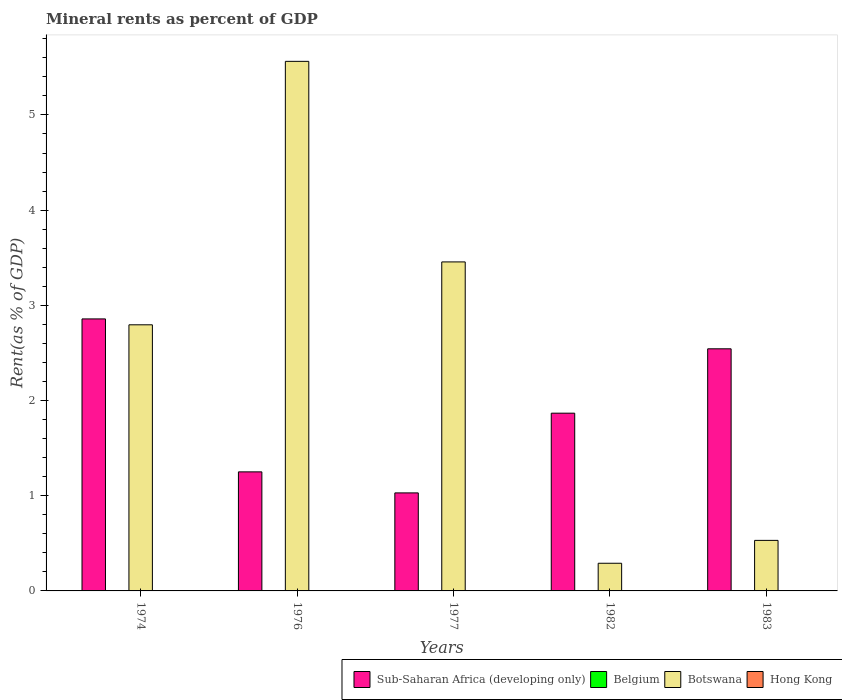How many different coloured bars are there?
Give a very brief answer. 4. How many groups of bars are there?
Make the answer very short. 5. How many bars are there on the 2nd tick from the right?
Your answer should be very brief. 4. What is the label of the 3rd group of bars from the left?
Offer a very short reply. 1977. What is the mineral rent in Hong Kong in 1983?
Make the answer very short. 0. Across all years, what is the maximum mineral rent in Botswana?
Give a very brief answer. 5.56. Across all years, what is the minimum mineral rent in Sub-Saharan Africa (developing only)?
Provide a succinct answer. 1.03. In which year was the mineral rent in Hong Kong maximum?
Make the answer very short. 1976. In which year was the mineral rent in Hong Kong minimum?
Offer a terse response. 1974. What is the total mineral rent in Hong Kong in the graph?
Ensure brevity in your answer.  0. What is the difference between the mineral rent in Belgium in 1976 and that in 1983?
Make the answer very short. 0. What is the difference between the mineral rent in Botswana in 1974 and the mineral rent in Belgium in 1983?
Make the answer very short. 2.8. What is the average mineral rent in Botswana per year?
Ensure brevity in your answer.  2.53. In the year 1976, what is the difference between the mineral rent in Hong Kong and mineral rent in Belgium?
Make the answer very short. -0. In how many years, is the mineral rent in Belgium greater than 5.6 %?
Keep it short and to the point. 0. What is the ratio of the mineral rent in Botswana in 1974 to that in 1983?
Keep it short and to the point. 5.27. Is the difference between the mineral rent in Hong Kong in 1976 and 1977 greater than the difference between the mineral rent in Belgium in 1976 and 1977?
Give a very brief answer. No. What is the difference between the highest and the second highest mineral rent in Hong Kong?
Provide a succinct answer. 0. What is the difference between the highest and the lowest mineral rent in Belgium?
Your response must be concise. 0. In how many years, is the mineral rent in Belgium greater than the average mineral rent in Belgium taken over all years?
Give a very brief answer. 2. Is the sum of the mineral rent in Sub-Saharan Africa (developing only) in 1977 and 1983 greater than the maximum mineral rent in Hong Kong across all years?
Provide a succinct answer. Yes. What does the 3rd bar from the left in 1983 represents?
Provide a short and direct response. Botswana. What does the 1st bar from the right in 1983 represents?
Give a very brief answer. Hong Kong. Are all the bars in the graph horizontal?
Your answer should be compact. No. What is the difference between two consecutive major ticks on the Y-axis?
Offer a terse response. 1. Does the graph contain any zero values?
Give a very brief answer. No. Where does the legend appear in the graph?
Make the answer very short. Bottom right. How many legend labels are there?
Your answer should be very brief. 4. What is the title of the graph?
Keep it short and to the point. Mineral rents as percent of GDP. Does "Israel" appear as one of the legend labels in the graph?
Give a very brief answer. No. What is the label or title of the X-axis?
Your response must be concise. Years. What is the label or title of the Y-axis?
Offer a very short reply. Rent(as % of GDP). What is the Rent(as % of GDP) in Sub-Saharan Africa (developing only) in 1974?
Ensure brevity in your answer.  2.86. What is the Rent(as % of GDP) in Belgium in 1974?
Give a very brief answer. 0. What is the Rent(as % of GDP) in Botswana in 1974?
Your response must be concise. 2.8. What is the Rent(as % of GDP) in Hong Kong in 1974?
Provide a short and direct response. 0. What is the Rent(as % of GDP) in Sub-Saharan Africa (developing only) in 1976?
Your answer should be compact. 1.25. What is the Rent(as % of GDP) in Belgium in 1976?
Provide a succinct answer. 0. What is the Rent(as % of GDP) in Botswana in 1976?
Ensure brevity in your answer.  5.56. What is the Rent(as % of GDP) in Hong Kong in 1976?
Your answer should be compact. 0. What is the Rent(as % of GDP) in Sub-Saharan Africa (developing only) in 1977?
Keep it short and to the point. 1.03. What is the Rent(as % of GDP) in Belgium in 1977?
Offer a very short reply. 0. What is the Rent(as % of GDP) of Botswana in 1977?
Ensure brevity in your answer.  3.46. What is the Rent(as % of GDP) of Hong Kong in 1977?
Make the answer very short. 0. What is the Rent(as % of GDP) of Sub-Saharan Africa (developing only) in 1982?
Provide a succinct answer. 1.87. What is the Rent(as % of GDP) in Belgium in 1982?
Ensure brevity in your answer.  5.1557649485168e-5. What is the Rent(as % of GDP) in Botswana in 1982?
Keep it short and to the point. 0.29. What is the Rent(as % of GDP) of Hong Kong in 1982?
Your answer should be very brief. 0. What is the Rent(as % of GDP) in Sub-Saharan Africa (developing only) in 1983?
Keep it short and to the point. 2.54. What is the Rent(as % of GDP) of Belgium in 1983?
Provide a succinct answer. 2.2873388575686e-5. What is the Rent(as % of GDP) of Botswana in 1983?
Provide a succinct answer. 0.53. What is the Rent(as % of GDP) of Hong Kong in 1983?
Your answer should be compact. 0. Across all years, what is the maximum Rent(as % of GDP) in Sub-Saharan Africa (developing only)?
Keep it short and to the point. 2.86. Across all years, what is the maximum Rent(as % of GDP) in Belgium?
Your response must be concise. 0. Across all years, what is the maximum Rent(as % of GDP) in Botswana?
Make the answer very short. 5.56. Across all years, what is the maximum Rent(as % of GDP) of Hong Kong?
Offer a very short reply. 0. Across all years, what is the minimum Rent(as % of GDP) in Sub-Saharan Africa (developing only)?
Your answer should be compact. 1.03. Across all years, what is the minimum Rent(as % of GDP) of Belgium?
Your response must be concise. 2.2873388575686e-5. Across all years, what is the minimum Rent(as % of GDP) of Botswana?
Make the answer very short. 0.29. Across all years, what is the minimum Rent(as % of GDP) of Hong Kong?
Provide a succinct answer. 0. What is the total Rent(as % of GDP) of Sub-Saharan Africa (developing only) in the graph?
Your response must be concise. 9.55. What is the total Rent(as % of GDP) in Belgium in the graph?
Your answer should be very brief. 0.01. What is the total Rent(as % of GDP) in Botswana in the graph?
Provide a short and direct response. 12.64. What is the total Rent(as % of GDP) of Hong Kong in the graph?
Make the answer very short. 0. What is the difference between the Rent(as % of GDP) in Sub-Saharan Africa (developing only) in 1974 and that in 1976?
Give a very brief answer. 1.61. What is the difference between the Rent(as % of GDP) in Belgium in 1974 and that in 1976?
Your answer should be very brief. -0. What is the difference between the Rent(as % of GDP) of Botswana in 1974 and that in 1976?
Ensure brevity in your answer.  -2.77. What is the difference between the Rent(as % of GDP) of Hong Kong in 1974 and that in 1976?
Provide a short and direct response. -0. What is the difference between the Rent(as % of GDP) of Sub-Saharan Africa (developing only) in 1974 and that in 1977?
Offer a terse response. 1.83. What is the difference between the Rent(as % of GDP) of Belgium in 1974 and that in 1977?
Make the answer very short. 0. What is the difference between the Rent(as % of GDP) in Botswana in 1974 and that in 1977?
Make the answer very short. -0.66. What is the difference between the Rent(as % of GDP) in Hong Kong in 1974 and that in 1977?
Offer a terse response. -0. What is the difference between the Rent(as % of GDP) in Sub-Saharan Africa (developing only) in 1974 and that in 1982?
Provide a succinct answer. 0.99. What is the difference between the Rent(as % of GDP) in Belgium in 1974 and that in 1982?
Make the answer very short. 0. What is the difference between the Rent(as % of GDP) of Botswana in 1974 and that in 1982?
Provide a short and direct response. 2.5. What is the difference between the Rent(as % of GDP) of Hong Kong in 1974 and that in 1982?
Keep it short and to the point. -0. What is the difference between the Rent(as % of GDP) of Sub-Saharan Africa (developing only) in 1974 and that in 1983?
Give a very brief answer. 0.31. What is the difference between the Rent(as % of GDP) of Belgium in 1974 and that in 1983?
Your answer should be very brief. 0. What is the difference between the Rent(as % of GDP) of Botswana in 1974 and that in 1983?
Offer a very short reply. 2.26. What is the difference between the Rent(as % of GDP) in Sub-Saharan Africa (developing only) in 1976 and that in 1977?
Provide a succinct answer. 0.22. What is the difference between the Rent(as % of GDP) of Belgium in 1976 and that in 1977?
Provide a short and direct response. 0. What is the difference between the Rent(as % of GDP) of Botswana in 1976 and that in 1977?
Your response must be concise. 2.11. What is the difference between the Rent(as % of GDP) of Sub-Saharan Africa (developing only) in 1976 and that in 1982?
Provide a short and direct response. -0.62. What is the difference between the Rent(as % of GDP) of Belgium in 1976 and that in 1982?
Offer a terse response. 0. What is the difference between the Rent(as % of GDP) of Botswana in 1976 and that in 1982?
Your answer should be compact. 5.27. What is the difference between the Rent(as % of GDP) in Hong Kong in 1976 and that in 1982?
Your answer should be compact. 0. What is the difference between the Rent(as % of GDP) of Sub-Saharan Africa (developing only) in 1976 and that in 1983?
Your response must be concise. -1.29. What is the difference between the Rent(as % of GDP) of Belgium in 1976 and that in 1983?
Give a very brief answer. 0. What is the difference between the Rent(as % of GDP) in Botswana in 1976 and that in 1983?
Your response must be concise. 5.03. What is the difference between the Rent(as % of GDP) of Hong Kong in 1976 and that in 1983?
Make the answer very short. 0. What is the difference between the Rent(as % of GDP) in Sub-Saharan Africa (developing only) in 1977 and that in 1982?
Your answer should be compact. -0.84. What is the difference between the Rent(as % of GDP) in Belgium in 1977 and that in 1982?
Your answer should be very brief. 0. What is the difference between the Rent(as % of GDP) in Botswana in 1977 and that in 1982?
Offer a very short reply. 3.17. What is the difference between the Rent(as % of GDP) of Hong Kong in 1977 and that in 1982?
Make the answer very short. 0. What is the difference between the Rent(as % of GDP) in Sub-Saharan Africa (developing only) in 1977 and that in 1983?
Give a very brief answer. -1.51. What is the difference between the Rent(as % of GDP) in Belgium in 1977 and that in 1983?
Offer a very short reply. 0. What is the difference between the Rent(as % of GDP) in Botswana in 1977 and that in 1983?
Ensure brevity in your answer.  2.93. What is the difference between the Rent(as % of GDP) of Hong Kong in 1977 and that in 1983?
Give a very brief answer. 0. What is the difference between the Rent(as % of GDP) of Sub-Saharan Africa (developing only) in 1982 and that in 1983?
Offer a terse response. -0.68. What is the difference between the Rent(as % of GDP) of Botswana in 1982 and that in 1983?
Provide a succinct answer. -0.24. What is the difference between the Rent(as % of GDP) of Sub-Saharan Africa (developing only) in 1974 and the Rent(as % of GDP) of Belgium in 1976?
Keep it short and to the point. 2.85. What is the difference between the Rent(as % of GDP) of Sub-Saharan Africa (developing only) in 1974 and the Rent(as % of GDP) of Botswana in 1976?
Provide a succinct answer. -2.71. What is the difference between the Rent(as % of GDP) in Sub-Saharan Africa (developing only) in 1974 and the Rent(as % of GDP) in Hong Kong in 1976?
Your response must be concise. 2.86. What is the difference between the Rent(as % of GDP) of Belgium in 1974 and the Rent(as % of GDP) of Botswana in 1976?
Provide a short and direct response. -5.56. What is the difference between the Rent(as % of GDP) of Belgium in 1974 and the Rent(as % of GDP) of Hong Kong in 1976?
Offer a terse response. 0. What is the difference between the Rent(as % of GDP) in Botswana in 1974 and the Rent(as % of GDP) in Hong Kong in 1976?
Keep it short and to the point. 2.79. What is the difference between the Rent(as % of GDP) of Sub-Saharan Africa (developing only) in 1974 and the Rent(as % of GDP) of Belgium in 1977?
Your answer should be compact. 2.86. What is the difference between the Rent(as % of GDP) in Sub-Saharan Africa (developing only) in 1974 and the Rent(as % of GDP) in Botswana in 1977?
Your answer should be very brief. -0.6. What is the difference between the Rent(as % of GDP) of Sub-Saharan Africa (developing only) in 1974 and the Rent(as % of GDP) of Hong Kong in 1977?
Make the answer very short. 2.86. What is the difference between the Rent(as % of GDP) in Belgium in 1974 and the Rent(as % of GDP) in Botswana in 1977?
Keep it short and to the point. -3.45. What is the difference between the Rent(as % of GDP) in Belgium in 1974 and the Rent(as % of GDP) in Hong Kong in 1977?
Offer a very short reply. 0. What is the difference between the Rent(as % of GDP) in Botswana in 1974 and the Rent(as % of GDP) in Hong Kong in 1977?
Your answer should be very brief. 2.79. What is the difference between the Rent(as % of GDP) of Sub-Saharan Africa (developing only) in 1974 and the Rent(as % of GDP) of Belgium in 1982?
Offer a very short reply. 2.86. What is the difference between the Rent(as % of GDP) of Sub-Saharan Africa (developing only) in 1974 and the Rent(as % of GDP) of Botswana in 1982?
Make the answer very short. 2.57. What is the difference between the Rent(as % of GDP) in Sub-Saharan Africa (developing only) in 1974 and the Rent(as % of GDP) in Hong Kong in 1982?
Offer a very short reply. 2.86. What is the difference between the Rent(as % of GDP) in Belgium in 1974 and the Rent(as % of GDP) in Botswana in 1982?
Give a very brief answer. -0.29. What is the difference between the Rent(as % of GDP) in Belgium in 1974 and the Rent(as % of GDP) in Hong Kong in 1982?
Offer a very short reply. 0. What is the difference between the Rent(as % of GDP) in Botswana in 1974 and the Rent(as % of GDP) in Hong Kong in 1982?
Offer a very short reply. 2.79. What is the difference between the Rent(as % of GDP) in Sub-Saharan Africa (developing only) in 1974 and the Rent(as % of GDP) in Belgium in 1983?
Your response must be concise. 2.86. What is the difference between the Rent(as % of GDP) in Sub-Saharan Africa (developing only) in 1974 and the Rent(as % of GDP) in Botswana in 1983?
Give a very brief answer. 2.33. What is the difference between the Rent(as % of GDP) of Sub-Saharan Africa (developing only) in 1974 and the Rent(as % of GDP) of Hong Kong in 1983?
Provide a succinct answer. 2.86. What is the difference between the Rent(as % of GDP) of Belgium in 1974 and the Rent(as % of GDP) of Botswana in 1983?
Make the answer very short. -0.53. What is the difference between the Rent(as % of GDP) in Belgium in 1974 and the Rent(as % of GDP) in Hong Kong in 1983?
Offer a terse response. 0. What is the difference between the Rent(as % of GDP) in Botswana in 1974 and the Rent(as % of GDP) in Hong Kong in 1983?
Offer a very short reply. 2.79. What is the difference between the Rent(as % of GDP) of Sub-Saharan Africa (developing only) in 1976 and the Rent(as % of GDP) of Belgium in 1977?
Keep it short and to the point. 1.25. What is the difference between the Rent(as % of GDP) in Sub-Saharan Africa (developing only) in 1976 and the Rent(as % of GDP) in Botswana in 1977?
Your answer should be compact. -2.21. What is the difference between the Rent(as % of GDP) in Sub-Saharan Africa (developing only) in 1976 and the Rent(as % of GDP) in Hong Kong in 1977?
Your answer should be very brief. 1.25. What is the difference between the Rent(as % of GDP) of Belgium in 1976 and the Rent(as % of GDP) of Botswana in 1977?
Provide a succinct answer. -3.45. What is the difference between the Rent(as % of GDP) of Belgium in 1976 and the Rent(as % of GDP) of Hong Kong in 1977?
Give a very brief answer. 0. What is the difference between the Rent(as % of GDP) in Botswana in 1976 and the Rent(as % of GDP) in Hong Kong in 1977?
Give a very brief answer. 5.56. What is the difference between the Rent(as % of GDP) in Sub-Saharan Africa (developing only) in 1976 and the Rent(as % of GDP) in Belgium in 1982?
Offer a very short reply. 1.25. What is the difference between the Rent(as % of GDP) of Sub-Saharan Africa (developing only) in 1976 and the Rent(as % of GDP) of Hong Kong in 1982?
Provide a succinct answer. 1.25. What is the difference between the Rent(as % of GDP) of Belgium in 1976 and the Rent(as % of GDP) of Botswana in 1982?
Give a very brief answer. -0.29. What is the difference between the Rent(as % of GDP) in Belgium in 1976 and the Rent(as % of GDP) in Hong Kong in 1982?
Offer a terse response. 0. What is the difference between the Rent(as % of GDP) of Botswana in 1976 and the Rent(as % of GDP) of Hong Kong in 1982?
Provide a short and direct response. 5.56. What is the difference between the Rent(as % of GDP) in Sub-Saharan Africa (developing only) in 1976 and the Rent(as % of GDP) in Belgium in 1983?
Provide a succinct answer. 1.25. What is the difference between the Rent(as % of GDP) of Sub-Saharan Africa (developing only) in 1976 and the Rent(as % of GDP) of Botswana in 1983?
Ensure brevity in your answer.  0.72. What is the difference between the Rent(as % of GDP) in Sub-Saharan Africa (developing only) in 1976 and the Rent(as % of GDP) in Hong Kong in 1983?
Ensure brevity in your answer.  1.25. What is the difference between the Rent(as % of GDP) in Belgium in 1976 and the Rent(as % of GDP) in Botswana in 1983?
Offer a terse response. -0.53. What is the difference between the Rent(as % of GDP) of Belgium in 1976 and the Rent(as % of GDP) of Hong Kong in 1983?
Keep it short and to the point. 0. What is the difference between the Rent(as % of GDP) of Botswana in 1976 and the Rent(as % of GDP) of Hong Kong in 1983?
Make the answer very short. 5.56. What is the difference between the Rent(as % of GDP) in Sub-Saharan Africa (developing only) in 1977 and the Rent(as % of GDP) in Belgium in 1982?
Your answer should be compact. 1.03. What is the difference between the Rent(as % of GDP) in Sub-Saharan Africa (developing only) in 1977 and the Rent(as % of GDP) in Botswana in 1982?
Provide a short and direct response. 0.74. What is the difference between the Rent(as % of GDP) of Sub-Saharan Africa (developing only) in 1977 and the Rent(as % of GDP) of Hong Kong in 1982?
Make the answer very short. 1.03. What is the difference between the Rent(as % of GDP) of Belgium in 1977 and the Rent(as % of GDP) of Botswana in 1982?
Your answer should be compact. -0.29. What is the difference between the Rent(as % of GDP) in Botswana in 1977 and the Rent(as % of GDP) in Hong Kong in 1982?
Your response must be concise. 3.46. What is the difference between the Rent(as % of GDP) in Sub-Saharan Africa (developing only) in 1977 and the Rent(as % of GDP) in Belgium in 1983?
Make the answer very short. 1.03. What is the difference between the Rent(as % of GDP) in Sub-Saharan Africa (developing only) in 1977 and the Rent(as % of GDP) in Botswana in 1983?
Offer a very short reply. 0.5. What is the difference between the Rent(as % of GDP) of Sub-Saharan Africa (developing only) in 1977 and the Rent(as % of GDP) of Hong Kong in 1983?
Offer a terse response. 1.03. What is the difference between the Rent(as % of GDP) in Belgium in 1977 and the Rent(as % of GDP) in Botswana in 1983?
Give a very brief answer. -0.53. What is the difference between the Rent(as % of GDP) of Belgium in 1977 and the Rent(as % of GDP) of Hong Kong in 1983?
Keep it short and to the point. 0. What is the difference between the Rent(as % of GDP) of Botswana in 1977 and the Rent(as % of GDP) of Hong Kong in 1983?
Offer a very short reply. 3.46. What is the difference between the Rent(as % of GDP) in Sub-Saharan Africa (developing only) in 1982 and the Rent(as % of GDP) in Belgium in 1983?
Your answer should be compact. 1.87. What is the difference between the Rent(as % of GDP) of Sub-Saharan Africa (developing only) in 1982 and the Rent(as % of GDP) of Botswana in 1983?
Keep it short and to the point. 1.34. What is the difference between the Rent(as % of GDP) in Sub-Saharan Africa (developing only) in 1982 and the Rent(as % of GDP) in Hong Kong in 1983?
Your response must be concise. 1.87. What is the difference between the Rent(as % of GDP) of Belgium in 1982 and the Rent(as % of GDP) of Botswana in 1983?
Give a very brief answer. -0.53. What is the difference between the Rent(as % of GDP) of Belgium in 1982 and the Rent(as % of GDP) of Hong Kong in 1983?
Your answer should be very brief. -0. What is the difference between the Rent(as % of GDP) in Botswana in 1982 and the Rent(as % of GDP) in Hong Kong in 1983?
Provide a succinct answer. 0.29. What is the average Rent(as % of GDP) of Sub-Saharan Africa (developing only) per year?
Give a very brief answer. 1.91. What is the average Rent(as % of GDP) of Belgium per year?
Offer a very short reply. 0. What is the average Rent(as % of GDP) in Botswana per year?
Offer a terse response. 2.53. What is the average Rent(as % of GDP) in Hong Kong per year?
Offer a terse response. 0. In the year 1974, what is the difference between the Rent(as % of GDP) in Sub-Saharan Africa (developing only) and Rent(as % of GDP) in Belgium?
Offer a very short reply. 2.85. In the year 1974, what is the difference between the Rent(as % of GDP) in Sub-Saharan Africa (developing only) and Rent(as % of GDP) in Botswana?
Your answer should be compact. 0.06. In the year 1974, what is the difference between the Rent(as % of GDP) of Sub-Saharan Africa (developing only) and Rent(as % of GDP) of Hong Kong?
Offer a terse response. 2.86. In the year 1974, what is the difference between the Rent(as % of GDP) of Belgium and Rent(as % of GDP) of Botswana?
Provide a short and direct response. -2.79. In the year 1974, what is the difference between the Rent(as % of GDP) in Belgium and Rent(as % of GDP) in Hong Kong?
Offer a terse response. 0. In the year 1974, what is the difference between the Rent(as % of GDP) of Botswana and Rent(as % of GDP) of Hong Kong?
Provide a succinct answer. 2.79. In the year 1976, what is the difference between the Rent(as % of GDP) in Sub-Saharan Africa (developing only) and Rent(as % of GDP) in Belgium?
Keep it short and to the point. 1.25. In the year 1976, what is the difference between the Rent(as % of GDP) in Sub-Saharan Africa (developing only) and Rent(as % of GDP) in Botswana?
Give a very brief answer. -4.31. In the year 1976, what is the difference between the Rent(as % of GDP) of Sub-Saharan Africa (developing only) and Rent(as % of GDP) of Hong Kong?
Provide a succinct answer. 1.25. In the year 1976, what is the difference between the Rent(as % of GDP) in Belgium and Rent(as % of GDP) in Botswana?
Make the answer very short. -5.56. In the year 1976, what is the difference between the Rent(as % of GDP) of Belgium and Rent(as % of GDP) of Hong Kong?
Provide a succinct answer. 0. In the year 1976, what is the difference between the Rent(as % of GDP) in Botswana and Rent(as % of GDP) in Hong Kong?
Your answer should be very brief. 5.56. In the year 1977, what is the difference between the Rent(as % of GDP) in Sub-Saharan Africa (developing only) and Rent(as % of GDP) in Belgium?
Your response must be concise. 1.03. In the year 1977, what is the difference between the Rent(as % of GDP) in Sub-Saharan Africa (developing only) and Rent(as % of GDP) in Botswana?
Offer a very short reply. -2.43. In the year 1977, what is the difference between the Rent(as % of GDP) in Sub-Saharan Africa (developing only) and Rent(as % of GDP) in Hong Kong?
Your answer should be compact. 1.03. In the year 1977, what is the difference between the Rent(as % of GDP) in Belgium and Rent(as % of GDP) in Botswana?
Your response must be concise. -3.45. In the year 1977, what is the difference between the Rent(as % of GDP) in Belgium and Rent(as % of GDP) in Hong Kong?
Provide a short and direct response. 0. In the year 1977, what is the difference between the Rent(as % of GDP) in Botswana and Rent(as % of GDP) in Hong Kong?
Your answer should be compact. 3.46. In the year 1982, what is the difference between the Rent(as % of GDP) in Sub-Saharan Africa (developing only) and Rent(as % of GDP) in Belgium?
Keep it short and to the point. 1.87. In the year 1982, what is the difference between the Rent(as % of GDP) in Sub-Saharan Africa (developing only) and Rent(as % of GDP) in Botswana?
Make the answer very short. 1.58. In the year 1982, what is the difference between the Rent(as % of GDP) in Sub-Saharan Africa (developing only) and Rent(as % of GDP) in Hong Kong?
Keep it short and to the point. 1.87. In the year 1982, what is the difference between the Rent(as % of GDP) of Belgium and Rent(as % of GDP) of Botswana?
Give a very brief answer. -0.29. In the year 1982, what is the difference between the Rent(as % of GDP) in Belgium and Rent(as % of GDP) in Hong Kong?
Ensure brevity in your answer.  -0. In the year 1982, what is the difference between the Rent(as % of GDP) in Botswana and Rent(as % of GDP) in Hong Kong?
Provide a short and direct response. 0.29. In the year 1983, what is the difference between the Rent(as % of GDP) in Sub-Saharan Africa (developing only) and Rent(as % of GDP) in Belgium?
Ensure brevity in your answer.  2.54. In the year 1983, what is the difference between the Rent(as % of GDP) in Sub-Saharan Africa (developing only) and Rent(as % of GDP) in Botswana?
Make the answer very short. 2.01. In the year 1983, what is the difference between the Rent(as % of GDP) in Sub-Saharan Africa (developing only) and Rent(as % of GDP) in Hong Kong?
Ensure brevity in your answer.  2.54. In the year 1983, what is the difference between the Rent(as % of GDP) in Belgium and Rent(as % of GDP) in Botswana?
Make the answer very short. -0.53. In the year 1983, what is the difference between the Rent(as % of GDP) in Belgium and Rent(as % of GDP) in Hong Kong?
Keep it short and to the point. -0. In the year 1983, what is the difference between the Rent(as % of GDP) in Botswana and Rent(as % of GDP) in Hong Kong?
Provide a succinct answer. 0.53. What is the ratio of the Rent(as % of GDP) in Sub-Saharan Africa (developing only) in 1974 to that in 1976?
Offer a terse response. 2.28. What is the ratio of the Rent(as % of GDP) in Belgium in 1974 to that in 1976?
Offer a very short reply. 0.84. What is the ratio of the Rent(as % of GDP) in Botswana in 1974 to that in 1976?
Make the answer very short. 0.5. What is the ratio of the Rent(as % of GDP) in Hong Kong in 1974 to that in 1976?
Your answer should be very brief. 0.33. What is the ratio of the Rent(as % of GDP) in Sub-Saharan Africa (developing only) in 1974 to that in 1977?
Offer a very short reply. 2.77. What is the ratio of the Rent(as % of GDP) of Belgium in 1974 to that in 1977?
Your answer should be compact. 1.83. What is the ratio of the Rent(as % of GDP) in Botswana in 1974 to that in 1977?
Your answer should be compact. 0.81. What is the ratio of the Rent(as % of GDP) in Hong Kong in 1974 to that in 1977?
Provide a succinct answer. 0.51. What is the ratio of the Rent(as % of GDP) in Sub-Saharan Africa (developing only) in 1974 to that in 1982?
Make the answer very short. 1.53. What is the ratio of the Rent(as % of GDP) in Belgium in 1974 to that in 1982?
Give a very brief answer. 54.96. What is the ratio of the Rent(as % of GDP) in Botswana in 1974 to that in 1982?
Provide a succinct answer. 9.62. What is the ratio of the Rent(as % of GDP) in Hong Kong in 1974 to that in 1982?
Your answer should be compact. 0.71. What is the ratio of the Rent(as % of GDP) of Sub-Saharan Africa (developing only) in 1974 to that in 1983?
Your answer should be very brief. 1.12. What is the ratio of the Rent(as % of GDP) in Belgium in 1974 to that in 1983?
Keep it short and to the point. 123.88. What is the ratio of the Rent(as % of GDP) in Botswana in 1974 to that in 1983?
Offer a very short reply. 5.27. What is the ratio of the Rent(as % of GDP) in Hong Kong in 1974 to that in 1983?
Offer a very short reply. 0.91. What is the ratio of the Rent(as % of GDP) in Sub-Saharan Africa (developing only) in 1976 to that in 1977?
Ensure brevity in your answer.  1.21. What is the ratio of the Rent(as % of GDP) in Belgium in 1976 to that in 1977?
Ensure brevity in your answer.  2.18. What is the ratio of the Rent(as % of GDP) in Botswana in 1976 to that in 1977?
Give a very brief answer. 1.61. What is the ratio of the Rent(as % of GDP) in Hong Kong in 1976 to that in 1977?
Keep it short and to the point. 1.52. What is the ratio of the Rent(as % of GDP) of Sub-Saharan Africa (developing only) in 1976 to that in 1982?
Your answer should be compact. 0.67. What is the ratio of the Rent(as % of GDP) of Belgium in 1976 to that in 1982?
Give a very brief answer. 65.55. What is the ratio of the Rent(as % of GDP) of Botswana in 1976 to that in 1982?
Provide a short and direct response. 19.15. What is the ratio of the Rent(as % of GDP) of Hong Kong in 1976 to that in 1982?
Ensure brevity in your answer.  2.14. What is the ratio of the Rent(as % of GDP) of Sub-Saharan Africa (developing only) in 1976 to that in 1983?
Ensure brevity in your answer.  0.49. What is the ratio of the Rent(as % of GDP) of Belgium in 1976 to that in 1983?
Provide a short and direct response. 147.76. What is the ratio of the Rent(as % of GDP) in Botswana in 1976 to that in 1983?
Give a very brief answer. 10.48. What is the ratio of the Rent(as % of GDP) in Hong Kong in 1976 to that in 1983?
Make the answer very short. 2.72. What is the ratio of the Rent(as % of GDP) in Sub-Saharan Africa (developing only) in 1977 to that in 1982?
Your response must be concise. 0.55. What is the ratio of the Rent(as % of GDP) of Belgium in 1977 to that in 1982?
Keep it short and to the point. 30.1. What is the ratio of the Rent(as % of GDP) of Botswana in 1977 to that in 1982?
Ensure brevity in your answer.  11.9. What is the ratio of the Rent(as % of GDP) in Hong Kong in 1977 to that in 1982?
Give a very brief answer. 1.41. What is the ratio of the Rent(as % of GDP) of Sub-Saharan Africa (developing only) in 1977 to that in 1983?
Make the answer very short. 0.4. What is the ratio of the Rent(as % of GDP) in Belgium in 1977 to that in 1983?
Offer a terse response. 67.84. What is the ratio of the Rent(as % of GDP) of Botswana in 1977 to that in 1983?
Provide a succinct answer. 6.51. What is the ratio of the Rent(as % of GDP) in Hong Kong in 1977 to that in 1983?
Provide a succinct answer. 1.79. What is the ratio of the Rent(as % of GDP) in Sub-Saharan Africa (developing only) in 1982 to that in 1983?
Offer a very short reply. 0.73. What is the ratio of the Rent(as % of GDP) in Belgium in 1982 to that in 1983?
Offer a very short reply. 2.25. What is the ratio of the Rent(as % of GDP) in Botswana in 1982 to that in 1983?
Make the answer very short. 0.55. What is the ratio of the Rent(as % of GDP) in Hong Kong in 1982 to that in 1983?
Keep it short and to the point. 1.27. What is the difference between the highest and the second highest Rent(as % of GDP) in Sub-Saharan Africa (developing only)?
Provide a short and direct response. 0.31. What is the difference between the highest and the second highest Rent(as % of GDP) in Botswana?
Ensure brevity in your answer.  2.11. What is the difference between the highest and the lowest Rent(as % of GDP) in Sub-Saharan Africa (developing only)?
Your answer should be compact. 1.83. What is the difference between the highest and the lowest Rent(as % of GDP) of Belgium?
Ensure brevity in your answer.  0. What is the difference between the highest and the lowest Rent(as % of GDP) of Botswana?
Offer a very short reply. 5.27. What is the difference between the highest and the lowest Rent(as % of GDP) of Hong Kong?
Ensure brevity in your answer.  0. 